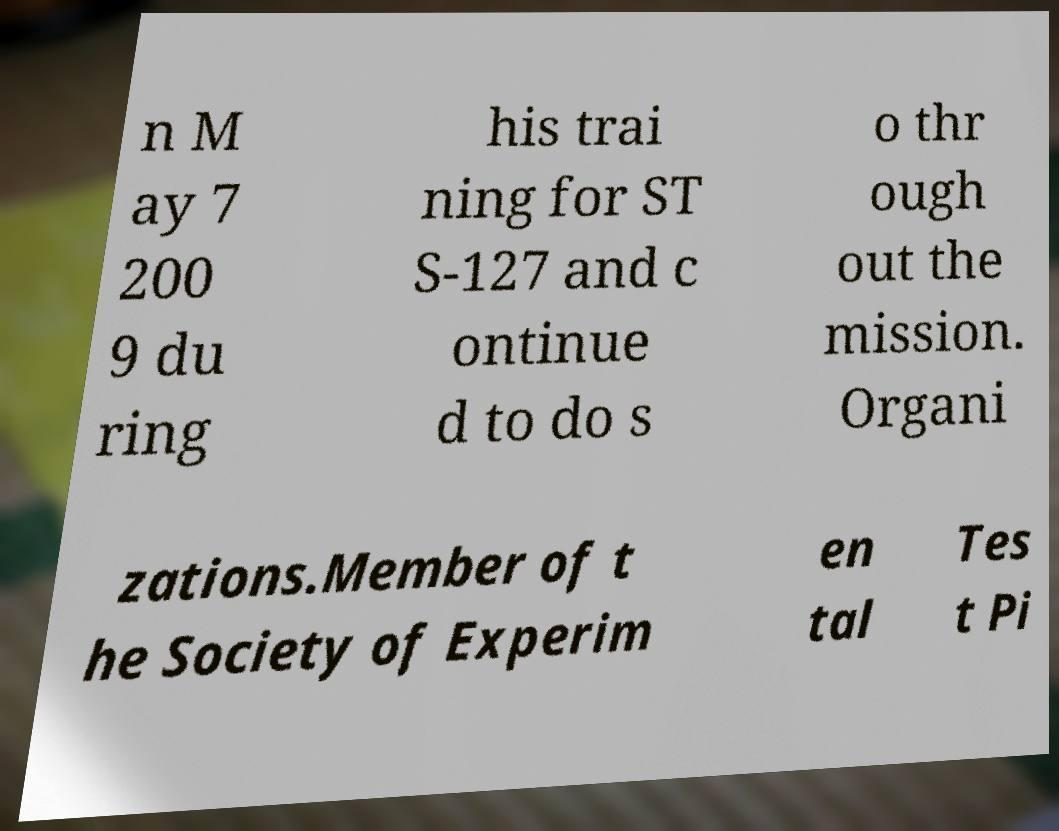Can you read and provide the text displayed in the image?This photo seems to have some interesting text. Can you extract and type it out for me? n M ay 7 200 9 du ring his trai ning for ST S-127 and c ontinue d to do s o thr ough out the mission. Organi zations.Member of t he Society of Experim en tal Tes t Pi 